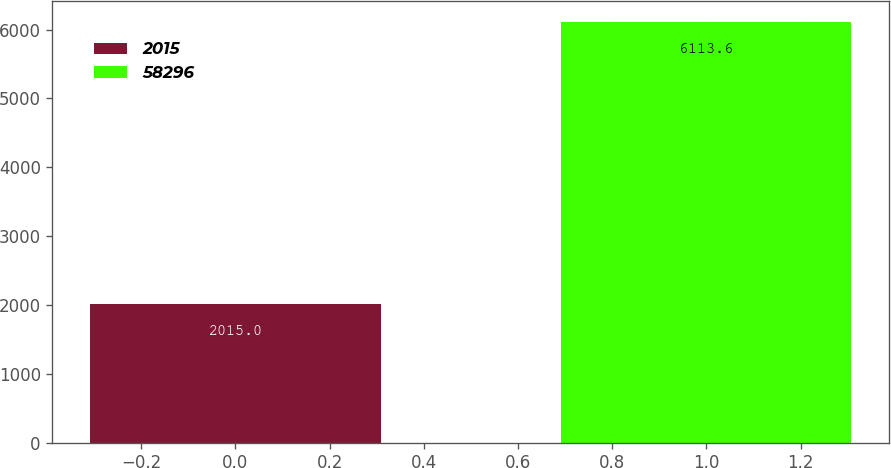<chart> <loc_0><loc_0><loc_500><loc_500><bar_chart><fcel>2015<fcel>58296<nl><fcel>2015<fcel>6113.6<nl></chart> 